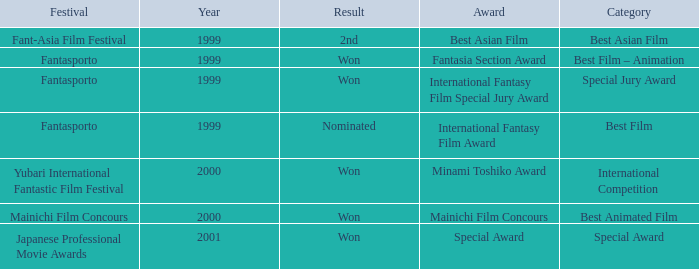What is the average year of the Fantasia Section Award? 1999.0. 